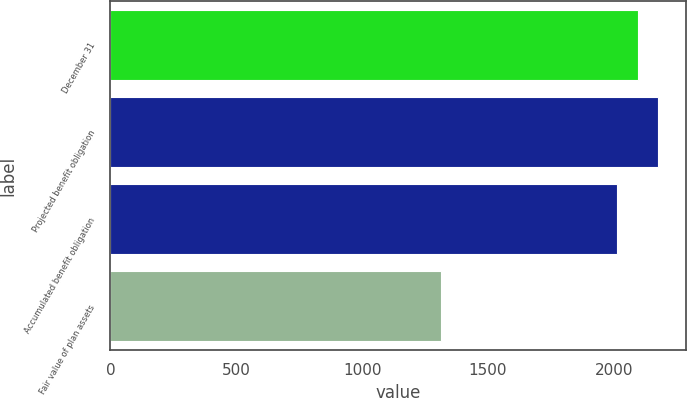Convert chart. <chart><loc_0><loc_0><loc_500><loc_500><bar_chart><fcel>December 31<fcel>Projected benefit obligation<fcel>Accumulated benefit obligation<fcel>Fair value of plan assets<nl><fcel>2095.5<fcel>2177<fcel>2014<fcel>1312<nl></chart> 